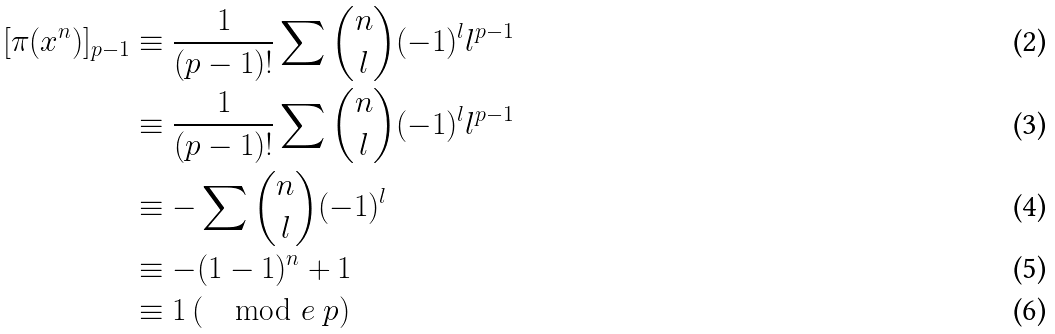Convert formula to latex. <formula><loc_0><loc_0><loc_500><loc_500>[ \pi ( x ^ { n } ) ] _ { p - 1 } & \equiv \frac { 1 } { ( p - 1 ) ! } \sum { { n \choose l } ( - 1 ) ^ { l } l ^ { p - 1 } } \\ & \equiv \frac { 1 } { ( p - 1 ) ! } \sum { { n \choose l } ( - 1 ) ^ { l } l ^ { p - 1 } } \\ & \equiv - \sum { { n \choose l } ( - 1 ) ^ { l } } \\ & \equiv - ( 1 - 1 ) ^ { n } + 1 \\ & \equiv 1 \, ( \mod e \ p )</formula> 